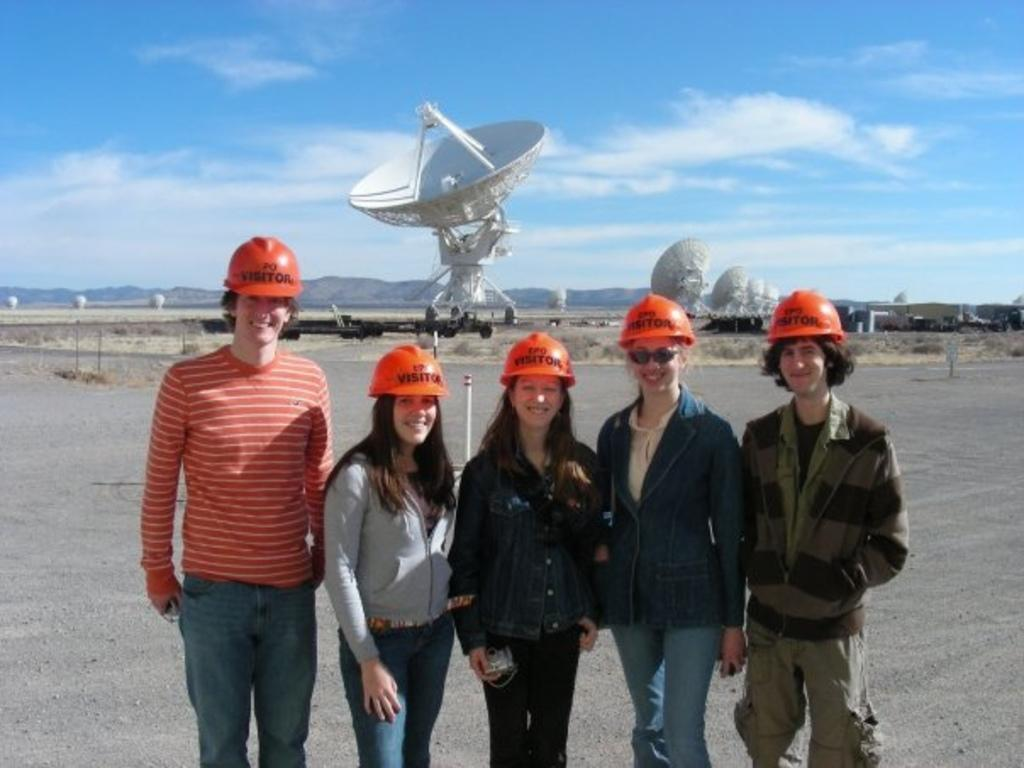How many people are in the image? There are five persons in the image. What are the persons wearing on their heads? The persons are wearing helmets. What can be seen in the background of the image? There are radio telescopes and mountains in the background of the image. What is visible in the sky in the image? The sky is visible in the background of the image. What type of tools does the carpenter use in the image? There is no carpenter present in the image, and therefore no tools can be observed. Can you tell me how many islands are visible in the image? There are no islands visible in the image; it features radio telescopes and mountains in the background. 